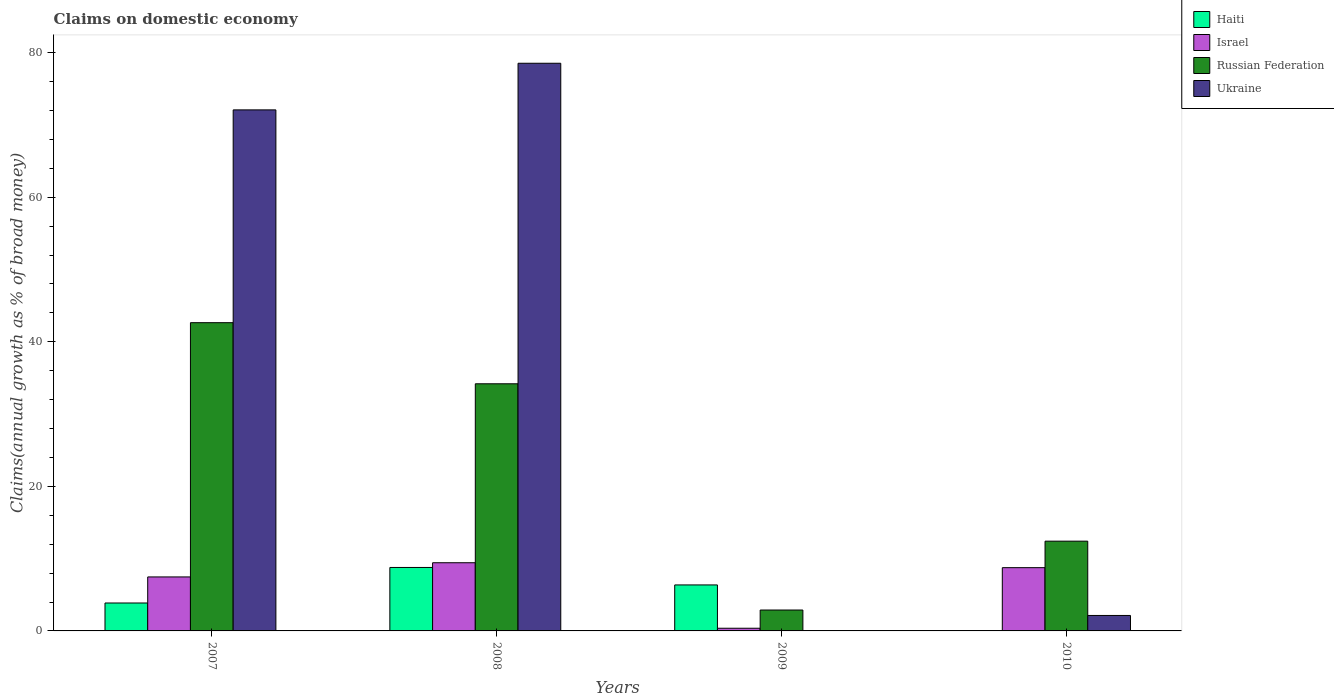How many different coloured bars are there?
Ensure brevity in your answer.  4. How many groups of bars are there?
Provide a short and direct response. 4. How many bars are there on the 4th tick from the left?
Give a very brief answer. 3. How many bars are there on the 3rd tick from the right?
Make the answer very short. 4. What is the percentage of broad money claimed on domestic economy in Israel in 2009?
Your response must be concise. 0.37. Across all years, what is the maximum percentage of broad money claimed on domestic economy in Ukraine?
Offer a terse response. 78.53. What is the total percentage of broad money claimed on domestic economy in Russian Federation in the graph?
Provide a short and direct response. 92.13. What is the difference between the percentage of broad money claimed on domestic economy in Israel in 2007 and that in 2010?
Your answer should be compact. -1.28. What is the difference between the percentage of broad money claimed on domestic economy in Israel in 2007 and the percentage of broad money claimed on domestic economy in Russian Federation in 2008?
Give a very brief answer. -26.72. What is the average percentage of broad money claimed on domestic economy in Ukraine per year?
Provide a succinct answer. 38.19. In the year 2010, what is the difference between the percentage of broad money claimed on domestic economy in Ukraine and percentage of broad money claimed on domestic economy in Israel?
Your answer should be very brief. -6.61. What is the ratio of the percentage of broad money claimed on domestic economy in Haiti in 2007 to that in 2009?
Keep it short and to the point. 0.61. Is the percentage of broad money claimed on domestic economy in Israel in 2008 less than that in 2010?
Ensure brevity in your answer.  No. Is the difference between the percentage of broad money claimed on domestic economy in Ukraine in 2007 and 2008 greater than the difference between the percentage of broad money claimed on domestic economy in Israel in 2007 and 2008?
Provide a succinct answer. No. What is the difference between the highest and the second highest percentage of broad money claimed on domestic economy in Ukraine?
Your response must be concise. 6.45. What is the difference between the highest and the lowest percentage of broad money claimed on domestic economy in Haiti?
Keep it short and to the point. 8.78. How many bars are there?
Offer a terse response. 14. Are all the bars in the graph horizontal?
Offer a terse response. No. What is the difference between two consecutive major ticks on the Y-axis?
Your answer should be very brief. 20. Are the values on the major ticks of Y-axis written in scientific E-notation?
Make the answer very short. No. Where does the legend appear in the graph?
Make the answer very short. Top right. What is the title of the graph?
Keep it short and to the point. Claims on domestic economy. What is the label or title of the Y-axis?
Keep it short and to the point. Claims(annual growth as % of broad money). What is the Claims(annual growth as % of broad money) in Haiti in 2007?
Your answer should be very brief. 3.86. What is the Claims(annual growth as % of broad money) of Israel in 2007?
Keep it short and to the point. 7.47. What is the Claims(annual growth as % of broad money) of Russian Federation in 2007?
Offer a very short reply. 42.64. What is the Claims(annual growth as % of broad money) in Ukraine in 2007?
Ensure brevity in your answer.  72.08. What is the Claims(annual growth as % of broad money) of Haiti in 2008?
Offer a terse response. 8.78. What is the Claims(annual growth as % of broad money) in Israel in 2008?
Ensure brevity in your answer.  9.43. What is the Claims(annual growth as % of broad money) of Russian Federation in 2008?
Make the answer very short. 34.19. What is the Claims(annual growth as % of broad money) in Ukraine in 2008?
Give a very brief answer. 78.53. What is the Claims(annual growth as % of broad money) of Haiti in 2009?
Keep it short and to the point. 6.36. What is the Claims(annual growth as % of broad money) in Israel in 2009?
Give a very brief answer. 0.37. What is the Claims(annual growth as % of broad money) in Russian Federation in 2009?
Give a very brief answer. 2.89. What is the Claims(annual growth as % of broad money) of Ukraine in 2009?
Make the answer very short. 0. What is the Claims(annual growth as % of broad money) in Haiti in 2010?
Your answer should be compact. 0. What is the Claims(annual growth as % of broad money) of Israel in 2010?
Give a very brief answer. 8.75. What is the Claims(annual growth as % of broad money) in Russian Federation in 2010?
Offer a very short reply. 12.42. What is the Claims(annual growth as % of broad money) of Ukraine in 2010?
Offer a terse response. 2.14. Across all years, what is the maximum Claims(annual growth as % of broad money) of Haiti?
Offer a very short reply. 8.78. Across all years, what is the maximum Claims(annual growth as % of broad money) of Israel?
Offer a terse response. 9.43. Across all years, what is the maximum Claims(annual growth as % of broad money) of Russian Federation?
Offer a terse response. 42.64. Across all years, what is the maximum Claims(annual growth as % of broad money) in Ukraine?
Ensure brevity in your answer.  78.53. Across all years, what is the minimum Claims(annual growth as % of broad money) in Israel?
Keep it short and to the point. 0.37. Across all years, what is the minimum Claims(annual growth as % of broad money) of Russian Federation?
Offer a very short reply. 2.89. What is the total Claims(annual growth as % of broad money) in Haiti in the graph?
Make the answer very short. 19. What is the total Claims(annual growth as % of broad money) of Israel in the graph?
Your answer should be very brief. 26.02. What is the total Claims(annual growth as % of broad money) of Russian Federation in the graph?
Offer a very short reply. 92.13. What is the total Claims(annual growth as % of broad money) in Ukraine in the graph?
Give a very brief answer. 152.74. What is the difference between the Claims(annual growth as % of broad money) in Haiti in 2007 and that in 2008?
Offer a very short reply. -4.92. What is the difference between the Claims(annual growth as % of broad money) in Israel in 2007 and that in 2008?
Your response must be concise. -1.96. What is the difference between the Claims(annual growth as % of broad money) of Russian Federation in 2007 and that in 2008?
Provide a short and direct response. 8.45. What is the difference between the Claims(annual growth as % of broad money) in Ukraine in 2007 and that in 2008?
Your response must be concise. -6.45. What is the difference between the Claims(annual growth as % of broad money) in Haiti in 2007 and that in 2009?
Ensure brevity in your answer.  -2.5. What is the difference between the Claims(annual growth as % of broad money) in Israel in 2007 and that in 2009?
Your answer should be very brief. 7.1. What is the difference between the Claims(annual growth as % of broad money) in Russian Federation in 2007 and that in 2009?
Give a very brief answer. 39.75. What is the difference between the Claims(annual growth as % of broad money) in Israel in 2007 and that in 2010?
Offer a terse response. -1.28. What is the difference between the Claims(annual growth as % of broad money) of Russian Federation in 2007 and that in 2010?
Offer a terse response. 30.22. What is the difference between the Claims(annual growth as % of broad money) of Ukraine in 2007 and that in 2010?
Ensure brevity in your answer.  69.94. What is the difference between the Claims(annual growth as % of broad money) of Haiti in 2008 and that in 2009?
Your answer should be compact. 2.42. What is the difference between the Claims(annual growth as % of broad money) in Israel in 2008 and that in 2009?
Ensure brevity in your answer.  9.06. What is the difference between the Claims(annual growth as % of broad money) in Russian Federation in 2008 and that in 2009?
Ensure brevity in your answer.  31.3. What is the difference between the Claims(annual growth as % of broad money) in Israel in 2008 and that in 2010?
Keep it short and to the point. 0.68. What is the difference between the Claims(annual growth as % of broad money) in Russian Federation in 2008 and that in 2010?
Your answer should be very brief. 21.77. What is the difference between the Claims(annual growth as % of broad money) in Ukraine in 2008 and that in 2010?
Offer a very short reply. 76.39. What is the difference between the Claims(annual growth as % of broad money) of Israel in 2009 and that in 2010?
Your response must be concise. -8.38. What is the difference between the Claims(annual growth as % of broad money) of Russian Federation in 2009 and that in 2010?
Give a very brief answer. -9.53. What is the difference between the Claims(annual growth as % of broad money) in Haiti in 2007 and the Claims(annual growth as % of broad money) in Israel in 2008?
Your answer should be very brief. -5.57. What is the difference between the Claims(annual growth as % of broad money) of Haiti in 2007 and the Claims(annual growth as % of broad money) of Russian Federation in 2008?
Provide a short and direct response. -30.32. What is the difference between the Claims(annual growth as % of broad money) in Haiti in 2007 and the Claims(annual growth as % of broad money) in Ukraine in 2008?
Your answer should be very brief. -74.66. What is the difference between the Claims(annual growth as % of broad money) of Israel in 2007 and the Claims(annual growth as % of broad money) of Russian Federation in 2008?
Give a very brief answer. -26.72. What is the difference between the Claims(annual growth as % of broad money) in Israel in 2007 and the Claims(annual growth as % of broad money) in Ukraine in 2008?
Keep it short and to the point. -71.06. What is the difference between the Claims(annual growth as % of broad money) in Russian Federation in 2007 and the Claims(annual growth as % of broad money) in Ukraine in 2008?
Make the answer very short. -35.89. What is the difference between the Claims(annual growth as % of broad money) of Haiti in 2007 and the Claims(annual growth as % of broad money) of Israel in 2009?
Your answer should be compact. 3.49. What is the difference between the Claims(annual growth as % of broad money) in Haiti in 2007 and the Claims(annual growth as % of broad money) in Russian Federation in 2009?
Provide a succinct answer. 0.97. What is the difference between the Claims(annual growth as % of broad money) of Israel in 2007 and the Claims(annual growth as % of broad money) of Russian Federation in 2009?
Offer a terse response. 4.58. What is the difference between the Claims(annual growth as % of broad money) of Haiti in 2007 and the Claims(annual growth as % of broad money) of Israel in 2010?
Provide a short and direct response. -4.89. What is the difference between the Claims(annual growth as % of broad money) in Haiti in 2007 and the Claims(annual growth as % of broad money) in Russian Federation in 2010?
Ensure brevity in your answer.  -8.55. What is the difference between the Claims(annual growth as % of broad money) of Haiti in 2007 and the Claims(annual growth as % of broad money) of Ukraine in 2010?
Offer a terse response. 1.72. What is the difference between the Claims(annual growth as % of broad money) of Israel in 2007 and the Claims(annual growth as % of broad money) of Russian Federation in 2010?
Offer a terse response. -4.95. What is the difference between the Claims(annual growth as % of broad money) in Israel in 2007 and the Claims(annual growth as % of broad money) in Ukraine in 2010?
Your answer should be very brief. 5.33. What is the difference between the Claims(annual growth as % of broad money) of Russian Federation in 2007 and the Claims(annual growth as % of broad money) of Ukraine in 2010?
Make the answer very short. 40.5. What is the difference between the Claims(annual growth as % of broad money) of Haiti in 2008 and the Claims(annual growth as % of broad money) of Israel in 2009?
Offer a very short reply. 8.41. What is the difference between the Claims(annual growth as % of broad money) in Haiti in 2008 and the Claims(annual growth as % of broad money) in Russian Federation in 2009?
Your answer should be very brief. 5.89. What is the difference between the Claims(annual growth as % of broad money) in Israel in 2008 and the Claims(annual growth as % of broad money) in Russian Federation in 2009?
Your response must be concise. 6.54. What is the difference between the Claims(annual growth as % of broad money) of Haiti in 2008 and the Claims(annual growth as % of broad money) of Israel in 2010?
Make the answer very short. 0.03. What is the difference between the Claims(annual growth as % of broad money) of Haiti in 2008 and the Claims(annual growth as % of broad money) of Russian Federation in 2010?
Make the answer very short. -3.64. What is the difference between the Claims(annual growth as % of broad money) in Haiti in 2008 and the Claims(annual growth as % of broad money) in Ukraine in 2010?
Offer a very short reply. 6.64. What is the difference between the Claims(annual growth as % of broad money) in Israel in 2008 and the Claims(annual growth as % of broad money) in Russian Federation in 2010?
Keep it short and to the point. -2.98. What is the difference between the Claims(annual growth as % of broad money) of Israel in 2008 and the Claims(annual growth as % of broad money) of Ukraine in 2010?
Give a very brief answer. 7.29. What is the difference between the Claims(annual growth as % of broad money) in Russian Federation in 2008 and the Claims(annual growth as % of broad money) in Ukraine in 2010?
Your response must be concise. 32.05. What is the difference between the Claims(annual growth as % of broad money) of Haiti in 2009 and the Claims(annual growth as % of broad money) of Israel in 2010?
Provide a short and direct response. -2.39. What is the difference between the Claims(annual growth as % of broad money) in Haiti in 2009 and the Claims(annual growth as % of broad money) in Russian Federation in 2010?
Give a very brief answer. -6.05. What is the difference between the Claims(annual growth as % of broad money) of Haiti in 2009 and the Claims(annual growth as % of broad money) of Ukraine in 2010?
Provide a succinct answer. 4.22. What is the difference between the Claims(annual growth as % of broad money) of Israel in 2009 and the Claims(annual growth as % of broad money) of Russian Federation in 2010?
Your answer should be very brief. -12.05. What is the difference between the Claims(annual growth as % of broad money) in Israel in 2009 and the Claims(annual growth as % of broad money) in Ukraine in 2010?
Give a very brief answer. -1.77. What is the difference between the Claims(annual growth as % of broad money) in Russian Federation in 2009 and the Claims(annual growth as % of broad money) in Ukraine in 2010?
Offer a terse response. 0.75. What is the average Claims(annual growth as % of broad money) in Haiti per year?
Offer a terse response. 4.75. What is the average Claims(annual growth as % of broad money) in Israel per year?
Make the answer very short. 6.51. What is the average Claims(annual growth as % of broad money) in Russian Federation per year?
Offer a terse response. 23.03. What is the average Claims(annual growth as % of broad money) of Ukraine per year?
Make the answer very short. 38.19. In the year 2007, what is the difference between the Claims(annual growth as % of broad money) in Haiti and Claims(annual growth as % of broad money) in Israel?
Give a very brief answer. -3.61. In the year 2007, what is the difference between the Claims(annual growth as % of broad money) in Haiti and Claims(annual growth as % of broad money) in Russian Federation?
Your answer should be compact. -38.78. In the year 2007, what is the difference between the Claims(annual growth as % of broad money) of Haiti and Claims(annual growth as % of broad money) of Ukraine?
Provide a succinct answer. -68.21. In the year 2007, what is the difference between the Claims(annual growth as % of broad money) of Israel and Claims(annual growth as % of broad money) of Russian Federation?
Keep it short and to the point. -35.17. In the year 2007, what is the difference between the Claims(annual growth as % of broad money) in Israel and Claims(annual growth as % of broad money) in Ukraine?
Give a very brief answer. -64.61. In the year 2007, what is the difference between the Claims(annual growth as % of broad money) of Russian Federation and Claims(annual growth as % of broad money) of Ukraine?
Keep it short and to the point. -29.44. In the year 2008, what is the difference between the Claims(annual growth as % of broad money) of Haiti and Claims(annual growth as % of broad money) of Israel?
Ensure brevity in your answer.  -0.65. In the year 2008, what is the difference between the Claims(annual growth as % of broad money) of Haiti and Claims(annual growth as % of broad money) of Russian Federation?
Your answer should be very brief. -25.41. In the year 2008, what is the difference between the Claims(annual growth as % of broad money) in Haiti and Claims(annual growth as % of broad money) in Ukraine?
Offer a terse response. -69.75. In the year 2008, what is the difference between the Claims(annual growth as % of broad money) of Israel and Claims(annual growth as % of broad money) of Russian Federation?
Ensure brevity in your answer.  -24.76. In the year 2008, what is the difference between the Claims(annual growth as % of broad money) in Israel and Claims(annual growth as % of broad money) in Ukraine?
Your answer should be compact. -69.1. In the year 2008, what is the difference between the Claims(annual growth as % of broad money) of Russian Federation and Claims(annual growth as % of broad money) of Ukraine?
Provide a succinct answer. -44.34. In the year 2009, what is the difference between the Claims(annual growth as % of broad money) of Haiti and Claims(annual growth as % of broad money) of Israel?
Ensure brevity in your answer.  5.99. In the year 2009, what is the difference between the Claims(annual growth as % of broad money) in Haiti and Claims(annual growth as % of broad money) in Russian Federation?
Ensure brevity in your answer.  3.47. In the year 2009, what is the difference between the Claims(annual growth as % of broad money) in Israel and Claims(annual growth as % of broad money) in Russian Federation?
Your answer should be very brief. -2.52. In the year 2010, what is the difference between the Claims(annual growth as % of broad money) of Israel and Claims(annual growth as % of broad money) of Russian Federation?
Your response must be concise. -3.66. In the year 2010, what is the difference between the Claims(annual growth as % of broad money) of Israel and Claims(annual growth as % of broad money) of Ukraine?
Give a very brief answer. 6.61. In the year 2010, what is the difference between the Claims(annual growth as % of broad money) in Russian Federation and Claims(annual growth as % of broad money) in Ukraine?
Make the answer very short. 10.28. What is the ratio of the Claims(annual growth as % of broad money) in Haiti in 2007 to that in 2008?
Your answer should be compact. 0.44. What is the ratio of the Claims(annual growth as % of broad money) of Israel in 2007 to that in 2008?
Keep it short and to the point. 0.79. What is the ratio of the Claims(annual growth as % of broad money) of Russian Federation in 2007 to that in 2008?
Your answer should be very brief. 1.25. What is the ratio of the Claims(annual growth as % of broad money) in Ukraine in 2007 to that in 2008?
Your answer should be very brief. 0.92. What is the ratio of the Claims(annual growth as % of broad money) in Haiti in 2007 to that in 2009?
Offer a terse response. 0.61. What is the ratio of the Claims(annual growth as % of broad money) in Israel in 2007 to that in 2009?
Give a very brief answer. 20.14. What is the ratio of the Claims(annual growth as % of broad money) in Russian Federation in 2007 to that in 2009?
Offer a terse response. 14.75. What is the ratio of the Claims(annual growth as % of broad money) of Israel in 2007 to that in 2010?
Your answer should be compact. 0.85. What is the ratio of the Claims(annual growth as % of broad money) of Russian Federation in 2007 to that in 2010?
Ensure brevity in your answer.  3.43. What is the ratio of the Claims(annual growth as % of broad money) in Ukraine in 2007 to that in 2010?
Provide a short and direct response. 33.69. What is the ratio of the Claims(annual growth as % of broad money) in Haiti in 2008 to that in 2009?
Offer a very short reply. 1.38. What is the ratio of the Claims(annual growth as % of broad money) in Israel in 2008 to that in 2009?
Your answer should be very brief. 25.43. What is the ratio of the Claims(annual growth as % of broad money) in Russian Federation in 2008 to that in 2009?
Give a very brief answer. 11.83. What is the ratio of the Claims(annual growth as % of broad money) of Israel in 2008 to that in 2010?
Your answer should be compact. 1.08. What is the ratio of the Claims(annual growth as % of broad money) of Russian Federation in 2008 to that in 2010?
Your response must be concise. 2.75. What is the ratio of the Claims(annual growth as % of broad money) of Ukraine in 2008 to that in 2010?
Your answer should be very brief. 36.71. What is the ratio of the Claims(annual growth as % of broad money) of Israel in 2009 to that in 2010?
Keep it short and to the point. 0.04. What is the ratio of the Claims(annual growth as % of broad money) of Russian Federation in 2009 to that in 2010?
Offer a terse response. 0.23. What is the difference between the highest and the second highest Claims(annual growth as % of broad money) in Haiti?
Offer a terse response. 2.42. What is the difference between the highest and the second highest Claims(annual growth as % of broad money) of Israel?
Offer a very short reply. 0.68. What is the difference between the highest and the second highest Claims(annual growth as % of broad money) of Russian Federation?
Make the answer very short. 8.45. What is the difference between the highest and the second highest Claims(annual growth as % of broad money) in Ukraine?
Provide a succinct answer. 6.45. What is the difference between the highest and the lowest Claims(annual growth as % of broad money) of Haiti?
Offer a terse response. 8.78. What is the difference between the highest and the lowest Claims(annual growth as % of broad money) of Israel?
Offer a very short reply. 9.06. What is the difference between the highest and the lowest Claims(annual growth as % of broad money) of Russian Federation?
Offer a terse response. 39.75. What is the difference between the highest and the lowest Claims(annual growth as % of broad money) in Ukraine?
Provide a short and direct response. 78.53. 